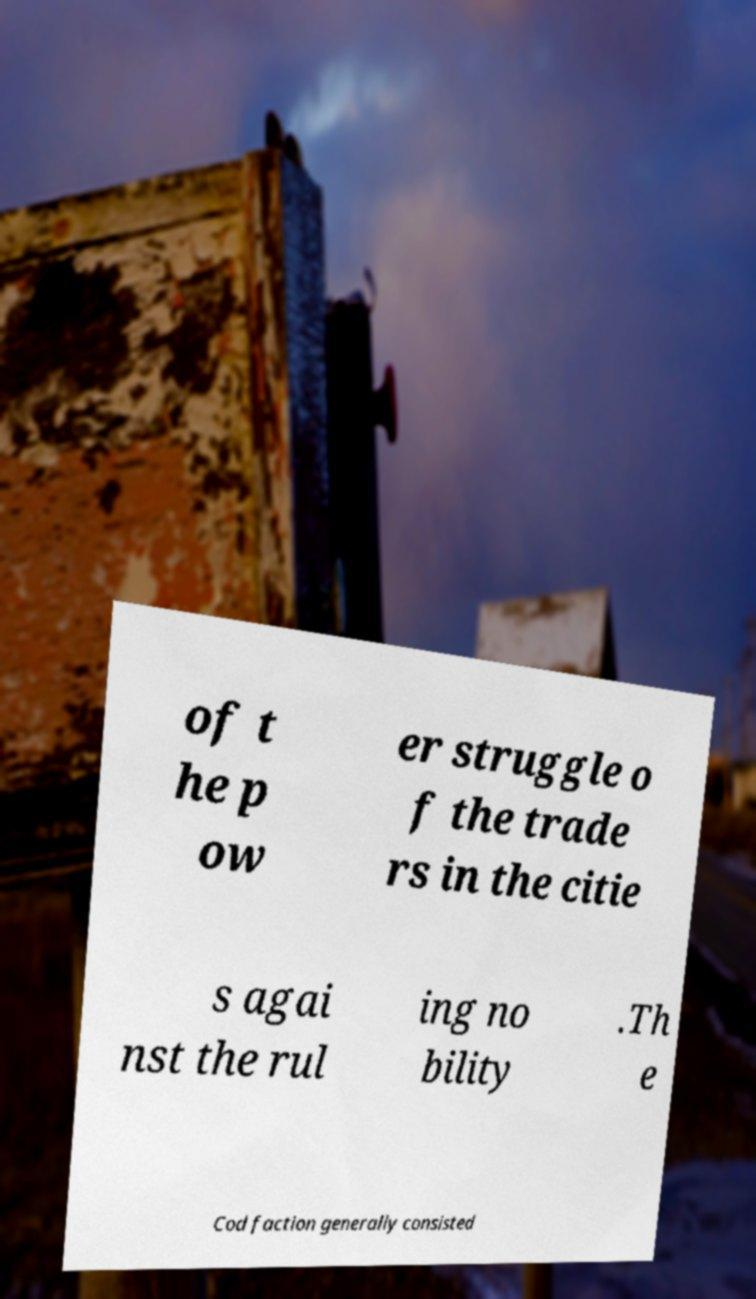Could you assist in decoding the text presented in this image and type it out clearly? of t he p ow er struggle o f the trade rs in the citie s agai nst the rul ing no bility .Th e Cod faction generally consisted 